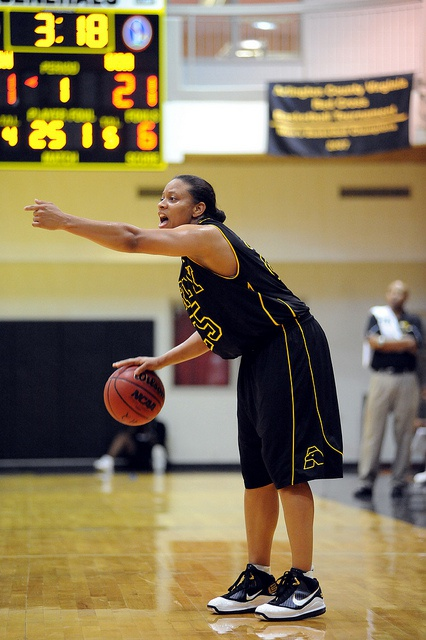Describe the objects in this image and their specific colors. I can see people in gray, black, brown, and tan tones, people in gray, darkgray, black, and lavender tones, clock in gray, black, yellow, and olive tones, sports ball in gray, brown, maroon, and black tones, and people in gray, black, and darkgray tones in this image. 